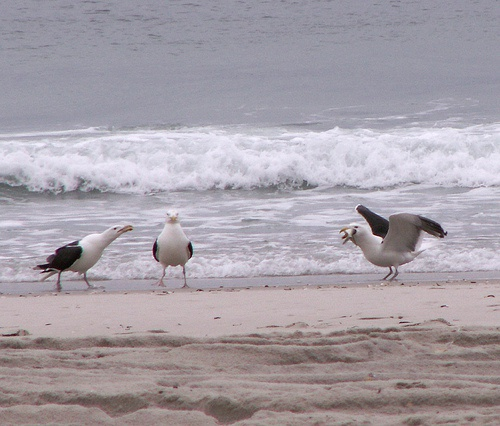Describe the objects in this image and their specific colors. I can see bird in darkgray, gray, and black tones, bird in darkgray, black, gray, and lightgray tones, and bird in darkgray, lightgray, and gray tones in this image. 